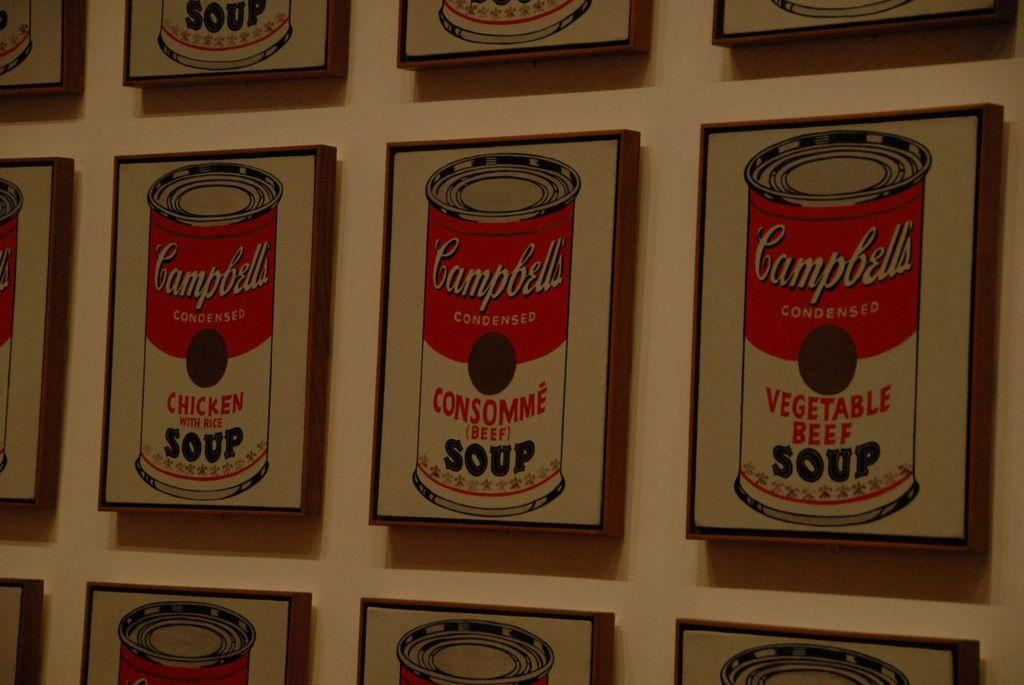<image>
Share a concise interpretation of the image provided. Several pictures of Campbell's soup cans, including chicken and vegetable beef, are hanging on a wall. 